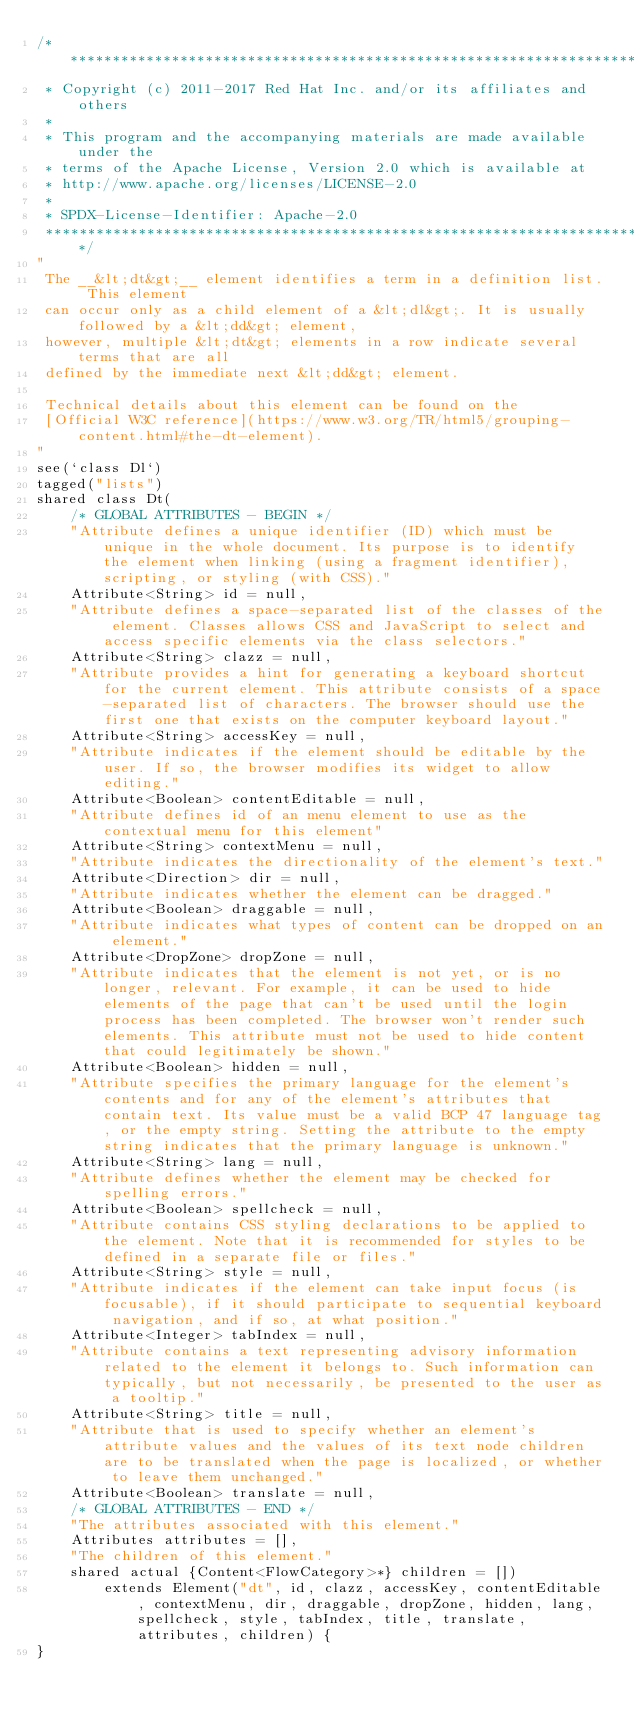<code> <loc_0><loc_0><loc_500><loc_500><_Ceylon_>/********************************************************************************
 * Copyright (c) 2011-2017 Red Hat Inc. and/or its affiliates and others
 *
 * This program and the accompanying materials are made available under the 
 * terms of the Apache License, Version 2.0 which is available at
 * http://www.apache.org/licenses/LICENSE-2.0
 *
 * SPDX-License-Identifier: Apache-2.0 
 ********************************************************************************/
"
 The __&lt;dt&gt;__ element identifies a term in a definition list. This element 
 can occur only as a child element of a &lt;dl&gt;. It is usually followed by a &lt;dd&gt; element, 
 however, multiple &lt;dt&gt; elements in a row indicate several terms that are all 
 defined by the immediate next &lt;dd&gt; element.
 
 Technical details about this element can be found on the
 [Official W3C reference](https://www.w3.org/TR/html5/grouping-content.html#the-dt-element).
"
see(`class Dl`)
tagged("lists")
shared class Dt(
    /* GLOBAL ATTRIBUTES - BEGIN */
    "Attribute defines a unique identifier (ID) which must be unique in the whole document. Its purpose is to identify the element when linking (using a fragment identifier), scripting, or styling (with CSS)."
    Attribute<String> id = null,
    "Attribute defines a space-separated list of the classes of the element. Classes allows CSS and JavaScript to select and access specific elements via the class selectors."
    Attribute<String> clazz = null,
    "Attribute provides a hint for generating a keyboard shortcut for the current element. This attribute consists of a space-separated list of characters. The browser should use the first one that exists on the computer keyboard layout."
    Attribute<String> accessKey = null,
    "Attribute indicates if the element should be editable by the user. If so, the browser modifies its widget to allow editing."
    Attribute<Boolean> contentEditable = null,
    "Attribute defines id of an menu element to use as the contextual menu for this element"
    Attribute<String> contextMenu = null,
    "Attribute indicates the directionality of the element's text."
    Attribute<Direction> dir = null,
    "Attribute indicates whether the element can be dragged."
    Attribute<Boolean> draggable = null,
    "Attribute indicates what types of content can be dropped on an element."
    Attribute<DropZone> dropZone = null,
    "Attribute indicates that the element is not yet, or is no longer, relevant. For example, it can be used to hide elements of the page that can't be used until the login process has been completed. The browser won't render such elements. This attribute must not be used to hide content that could legitimately be shown."
    Attribute<Boolean> hidden = null,
    "Attribute specifies the primary language for the element's contents and for any of the element's attributes that contain text. Its value must be a valid BCP 47 language tag, or the empty string. Setting the attribute to the empty string indicates that the primary language is unknown."
    Attribute<String> lang = null,
    "Attribute defines whether the element may be checked for spelling errors."
    Attribute<Boolean> spellcheck = null,
    "Attribute contains CSS styling declarations to be applied to the element. Note that it is recommended for styles to be defined in a separate file or files."
    Attribute<String> style = null,
    "Attribute indicates if the element can take input focus (is focusable), if it should participate to sequential keyboard navigation, and if so, at what position."
    Attribute<Integer> tabIndex = null,
    "Attribute contains a text representing advisory information related to the element it belongs to. Such information can typically, but not necessarily, be presented to the user as a tooltip."
    Attribute<String> title = null,
    "Attribute that is used to specify whether an element's attribute values and the values of its text node children are to be translated when the page is localized, or whether to leave them unchanged."
    Attribute<Boolean> translate = null,
    /* GLOBAL ATTRIBUTES - END */
    "The attributes associated with this element."
    Attributes attributes = [],
    "The children of this element."
    shared actual {Content<FlowCategory>*} children = [])
        extends Element("dt", id, clazz, accessKey, contentEditable, contextMenu, dir, draggable, dropZone, hidden, lang, spellcheck, style, tabIndex, title, translate, attributes, children) {
}</code> 